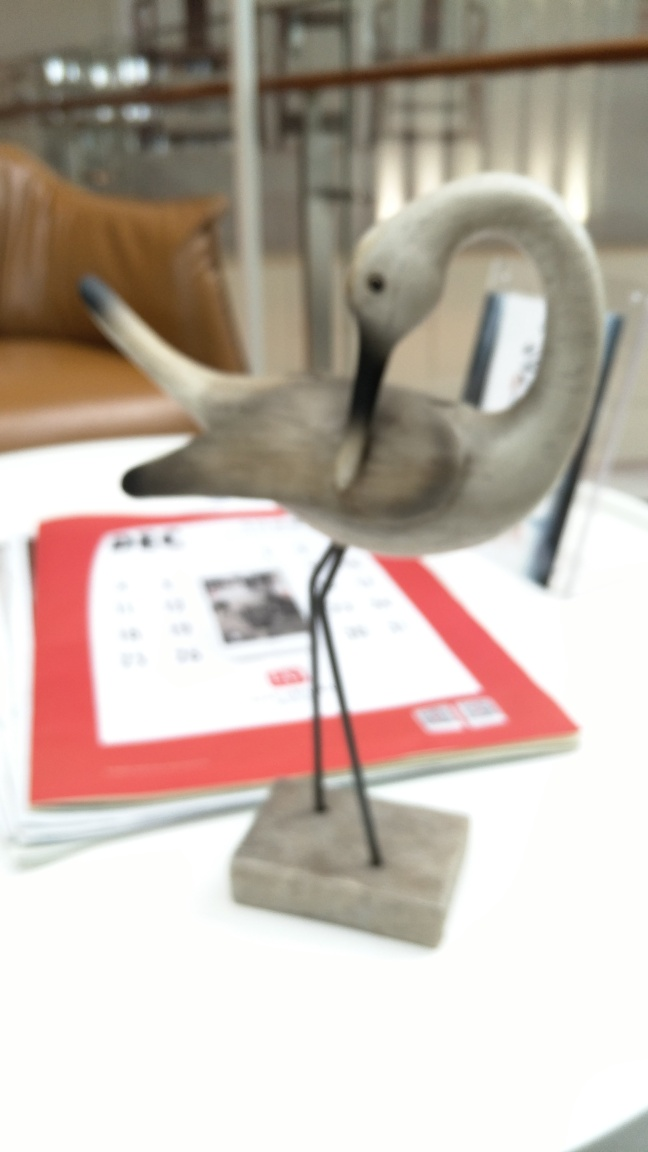What kind of crane is shown in the image? This seems to be a blurred image of a decorative crane, potentially crafted from wood or metal, placed on top of some printed material. 